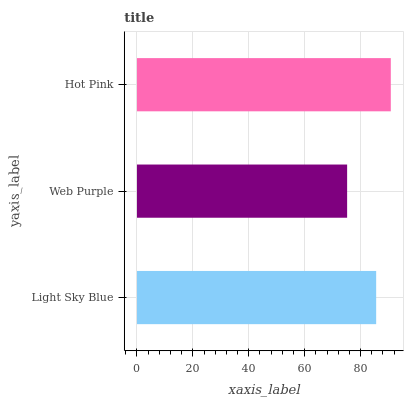Is Web Purple the minimum?
Answer yes or no. Yes. Is Hot Pink the maximum?
Answer yes or no. Yes. Is Hot Pink the minimum?
Answer yes or no. No. Is Web Purple the maximum?
Answer yes or no. No. Is Hot Pink greater than Web Purple?
Answer yes or no. Yes. Is Web Purple less than Hot Pink?
Answer yes or no. Yes. Is Web Purple greater than Hot Pink?
Answer yes or no. No. Is Hot Pink less than Web Purple?
Answer yes or no. No. Is Light Sky Blue the high median?
Answer yes or no. Yes. Is Light Sky Blue the low median?
Answer yes or no. Yes. Is Hot Pink the high median?
Answer yes or no. No. Is Hot Pink the low median?
Answer yes or no. No. 